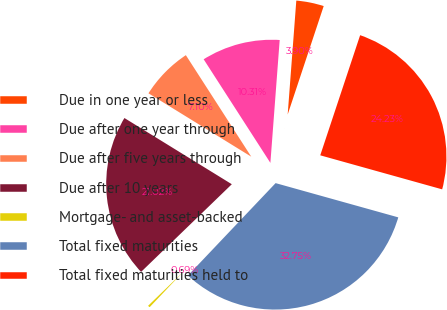Convert chart. <chart><loc_0><loc_0><loc_500><loc_500><pie_chart><fcel>Due in one year or less<fcel>Due after one year through<fcel>Due after five years through<fcel>Due after 10 years<fcel>Mortgage- and asset-backed<fcel>Total fixed maturities<fcel>Total fixed maturities held to<nl><fcel>3.9%<fcel>10.31%<fcel>7.1%<fcel>21.02%<fcel>0.69%<fcel>32.75%<fcel>24.23%<nl></chart> 